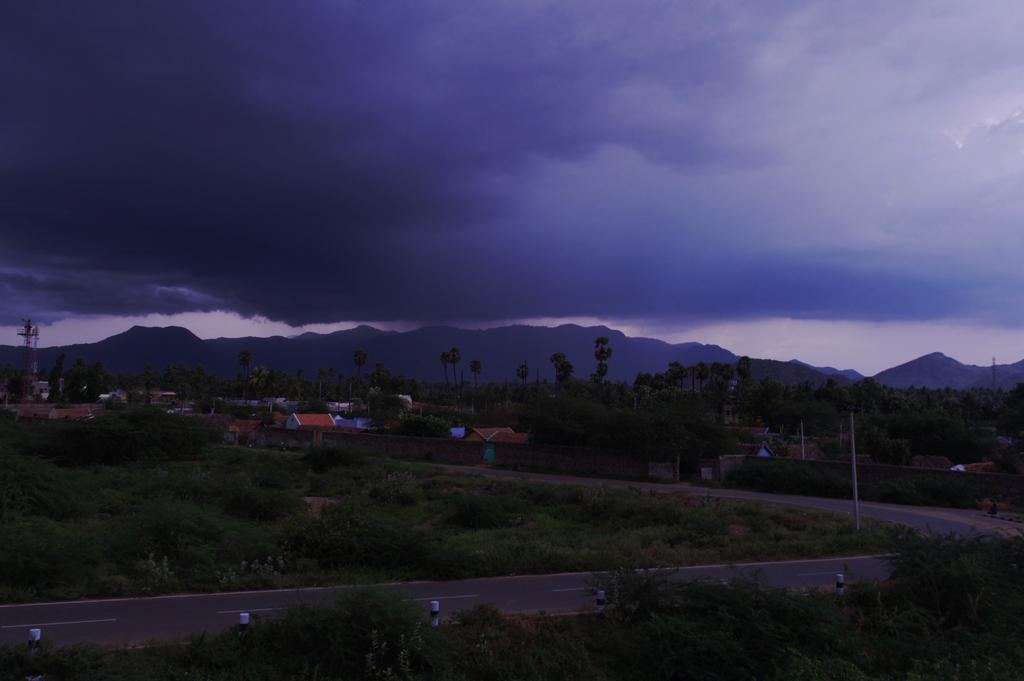What is the main feature in the center of the image? There is a road in the center of the image. What type of natural elements can be seen in the image? There are plants, mountains, trees, and clouds visible in the image. What type of man-made structures are present in the background of the image? There are houses in the background of the image. What is visible at the top of the image? The sky is visible at the top of the image, along with clouds. Can you see a bomb exploding in the image? No, there is no bomb or explosion present in the image. Is there a robin perched on one of the trees in the image? There is no robin visible in the image; only plants, mountains, trees, and clouds can be seen. 